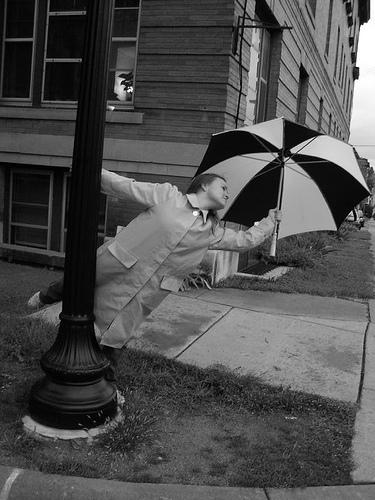What movie is the man copying?
Write a very short answer. Singing in rain. Can this man easily fall on the post?
Short answer required. Yes. What has been carved into the sidewalk?
Be succinct. Nothing. Do you see a clock?
Concise answer only. No. What kind of coat is the man wearing?
Keep it brief. Raincoat. What is the man standing next to?
Be succinct. Pole. 